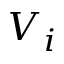<formula> <loc_0><loc_0><loc_500><loc_500>V _ { i }</formula> 